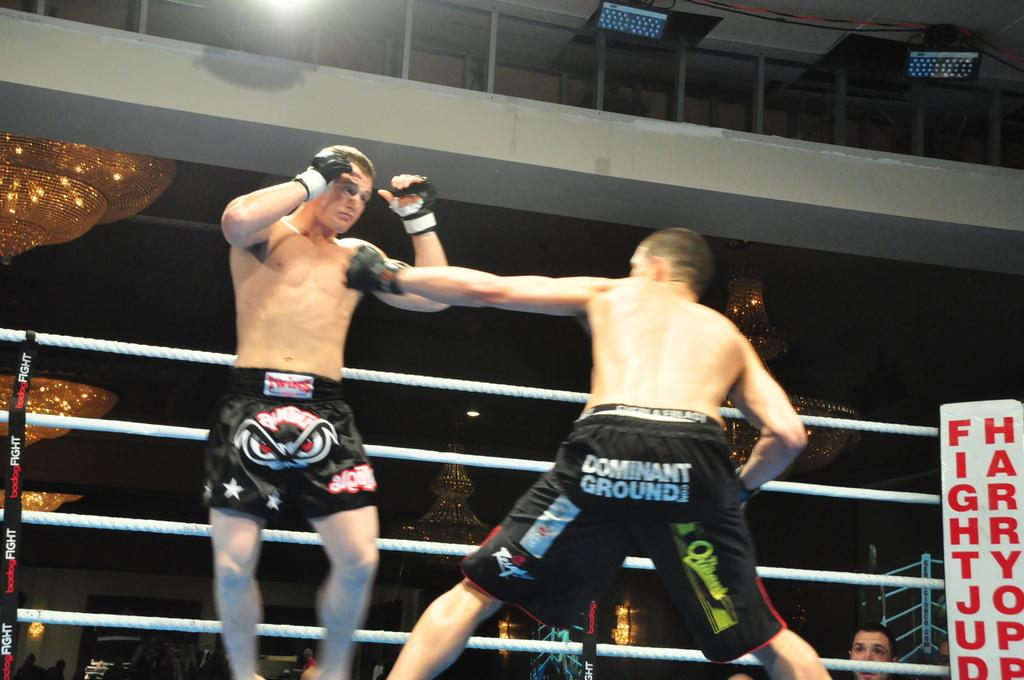<image>
Share a concise interpretation of the image provided. A boxer wears shorts with dominant ground on the backside. 